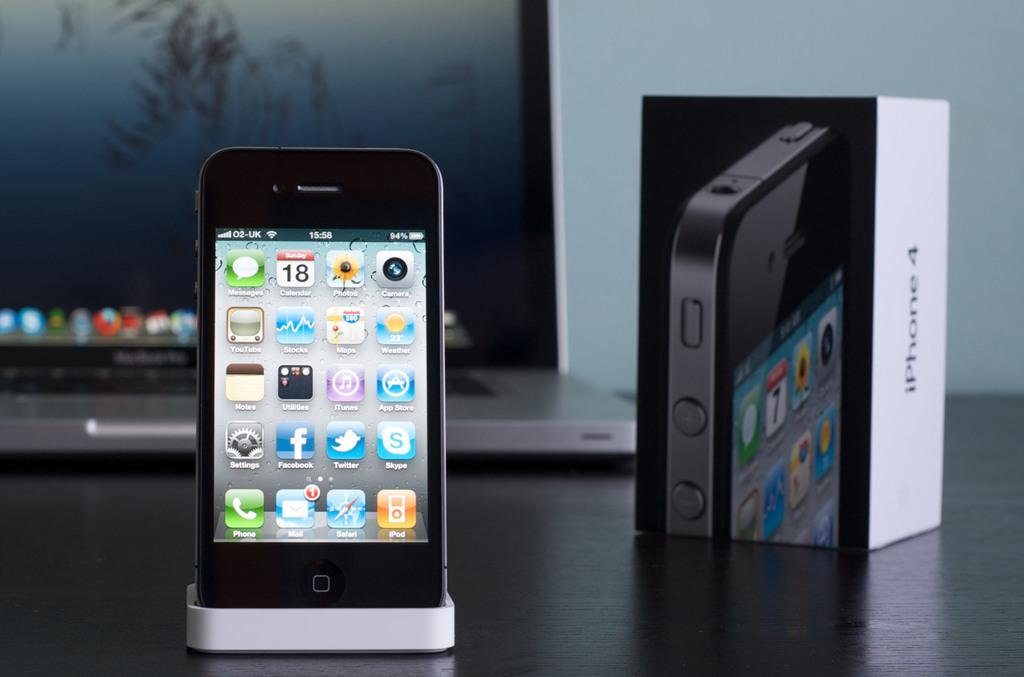<image>
Share a concise interpretation of the image provided. An iPhone 4 in a standing cradle in front of a laptop on a table. 